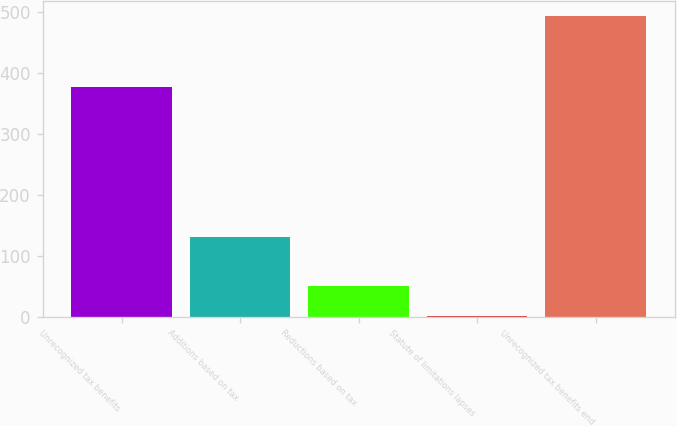<chart> <loc_0><loc_0><loc_500><loc_500><bar_chart><fcel>Unrecognized tax benefits<fcel>Additions based on tax<fcel>Reductions based on tax<fcel>Statute of limitations lapses<fcel>Unrecognized tax benefits end<nl><fcel>377<fcel>131<fcel>50.1<fcel>1<fcel>492<nl></chart> 